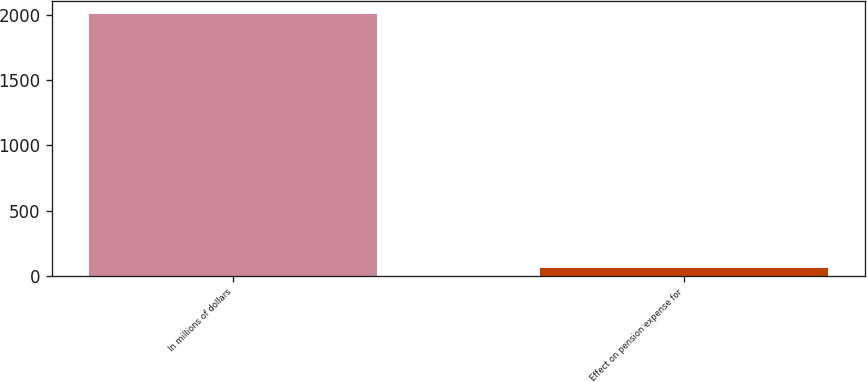<chart> <loc_0><loc_0><loc_500><loc_500><bar_chart><fcel>In millions of dollars<fcel>Effect on pension expense for<nl><fcel>2007<fcel>59<nl></chart> 